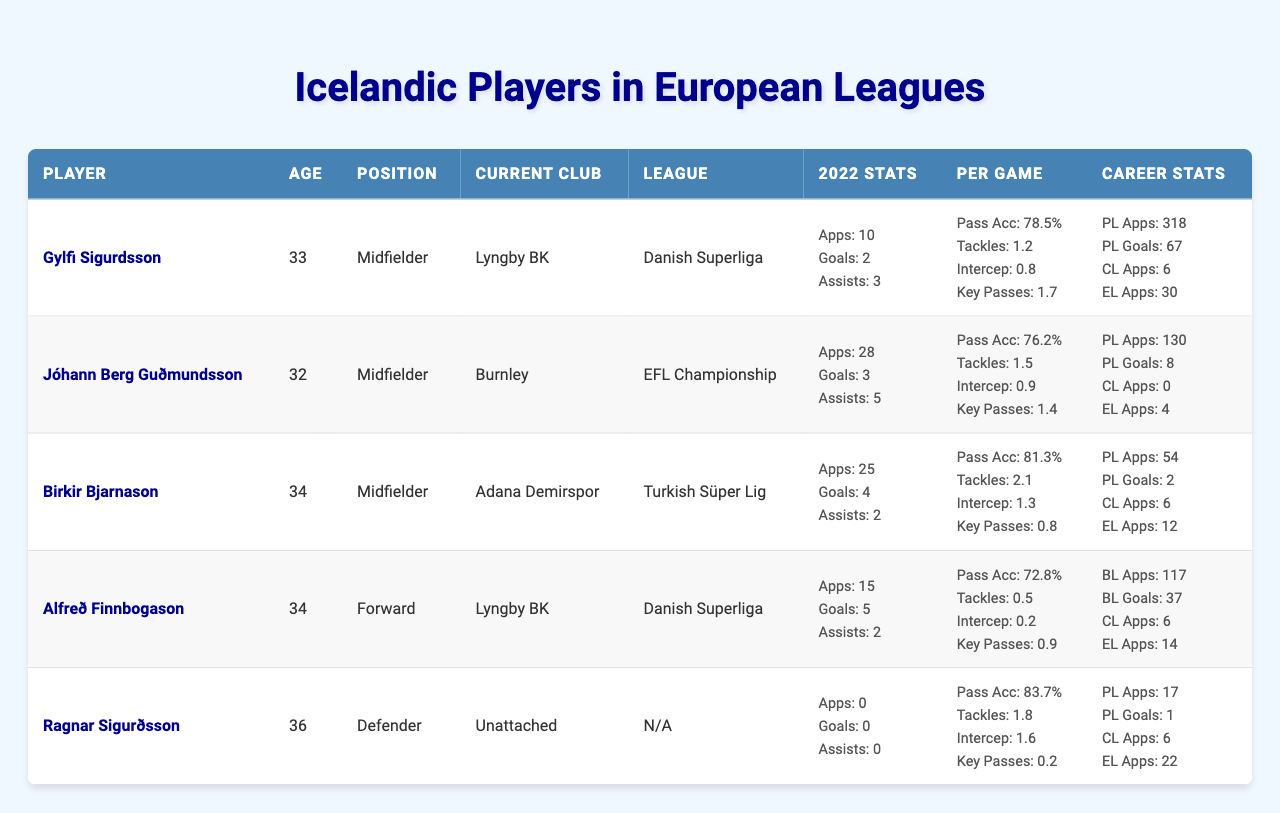What is the age of Gylfi Sigurdsson? Gylfi Sigurdsson's age is listed in the table, and it shows 33.
Answer: 33 How many assists did Jóhann Berg Guðmundsson have in 2022? The table indicates that Jóhann Berg Guðmundsson had 5 assists in 2022.
Answer: 5 What is Birkir Bjarnason's pass accuracy percentage? The table provides Birkir Bjarnason's pass accuracy as 81.3%.
Answer: 81.3% Who scored more goals in 2022, Alfreð Finnbogason or Birkir Bjarnason? Alfreð Finnbogason scored 5 goals while Birkir Bjarnason scored 4 goals, thus Alfreð Finnbogason scored more.
Answer: Alfreð Finnbogason What was the total number of appearances by Jóhann Berg Guðmundsson in 2022? According to the table, Jóhann Berg Guðmundsson had a total of 28 appearances in 2022.
Answer: 28 How many players in the table are currently unattached? There is one player in the table, Ragnar Sigurðsson, who is currently listed as unattached.
Answer: 1 What is the average number of goals scored by the players listed in the table in 2022? The total goals from all players are 2 (Sigurdsson) + 3 (Guðmundsson) + 4 (Bjarnason) + 5 (Finnbogason) + 0 (Sigurðsson) = 14. There are 5 players, so the average is 14/5 = 2.8.
Answer: 2.8 Which player has the highest number of premier league appearances? Gylfi Sigurdsson has the highest number of premier league appearances with 318.
Answer: 318 Did Ragnar Sigurðsson play any matches in 2022? The table shows that Ragnar Sigurðsson had 0 appearances in 2022. Therefore, the answer is no.
Answer: No Which player had the most tackles per game in the table? Birkir Bjarnason had the most tackles per game with 2.1 tackles nationally.
Answer: 2.1 How does Alfreð Finnbogason's assist record compare to Gylfi Sigurdsson's for 2022? Alfreð Finnbogason had 2 assists, while Gylfi Sigurdsson had 3 assists in 2022. Thus, Sigurdsson had more assists.
Answer: Gylfi Sigurdsson What is the difference in key passes per game between Jóhann Berg Guðmundsson and Birkir Bjarnason? Jóhann Berg Guðmundsson made 1.4 key passes per game while Birkir Bjarnason made 0.8 key passes per game. The difference is 1.4 - 0.8 = 0.6.
Answer: 0.6 Which player's statistics indicate they played the least in 2022? Ragnar Sigurðsson did not play in 2022 with 0 appearances, indicating he had the least activity.
Answer: Ragnar Sigurðsson What league is Jóhann Berg Guðmundsson currently playing in? The table states that Jóhann Berg Guðmundsson is currently playing in the EFL Championship with Burnley.
Answer: EFL Championship 